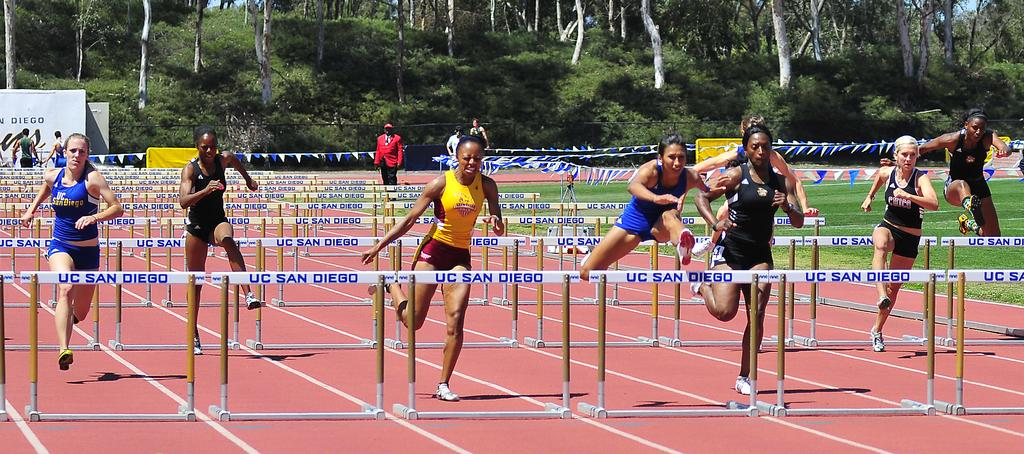<image>
Render a clear and concise summary of the photo. A group of track and field athletes compete at UC San Diego. 